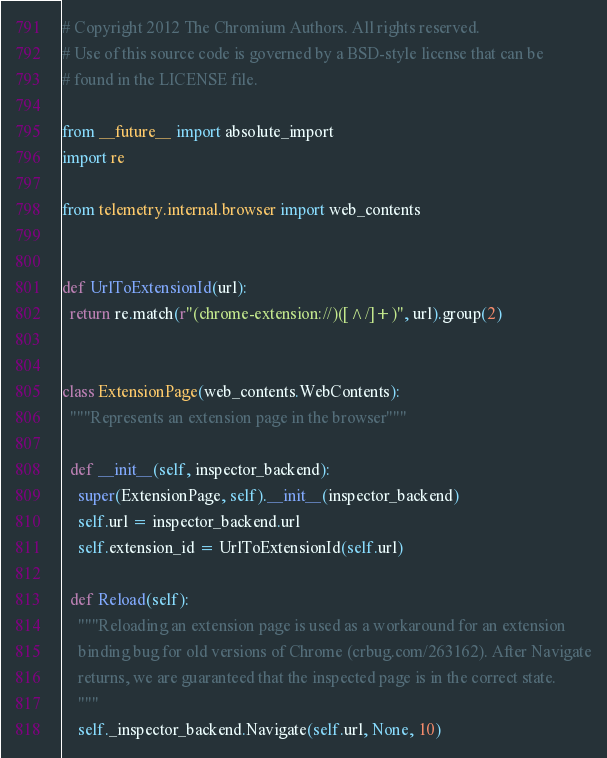Convert code to text. <code><loc_0><loc_0><loc_500><loc_500><_Python_># Copyright 2012 The Chromium Authors. All rights reserved.
# Use of this source code is governed by a BSD-style license that can be
# found in the LICENSE file.

from __future__ import absolute_import
import re

from telemetry.internal.browser import web_contents


def UrlToExtensionId(url):
  return re.match(r"(chrome-extension://)([^/]+)", url).group(2)


class ExtensionPage(web_contents.WebContents):
  """Represents an extension page in the browser"""

  def __init__(self, inspector_backend):
    super(ExtensionPage, self).__init__(inspector_backend)
    self.url = inspector_backend.url
    self.extension_id = UrlToExtensionId(self.url)

  def Reload(self):
    """Reloading an extension page is used as a workaround for an extension
    binding bug for old versions of Chrome (crbug.com/263162). After Navigate
    returns, we are guaranteed that the inspected page is in the correct state.
    """
    self._inspector_backend.Navigate(self.url, None, 10)
</code> 